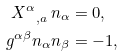<formula> <loc_0><loc_0><loc_500><loc_500>X ^ { \alpha } _ { \ , a } \, n _ { \alpha } & = 0 , \\ g ^ { \alpha \beta } n _ { \alpha } n _ { \beta } & = - 1 ,</formula> 